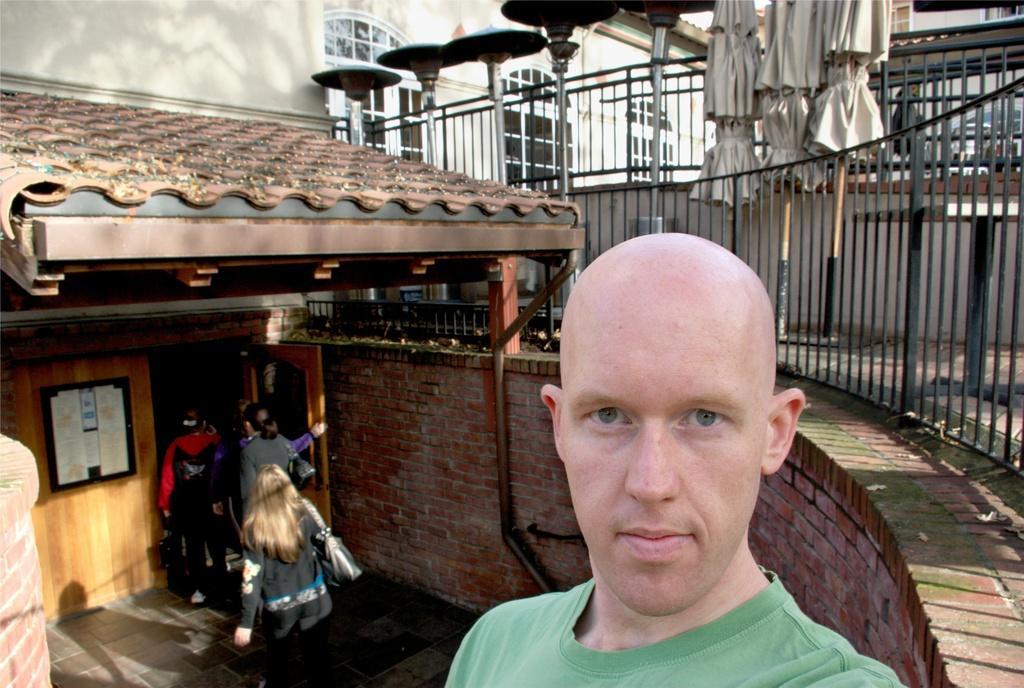Can you describe this image briefly? In the foreground of this image, there is a man with bald head. On the right, there are railings, light poles and umbrellas. On the left, there is a building, note board, wall, persons walking on the floor and the door. In the background, there is a building. 